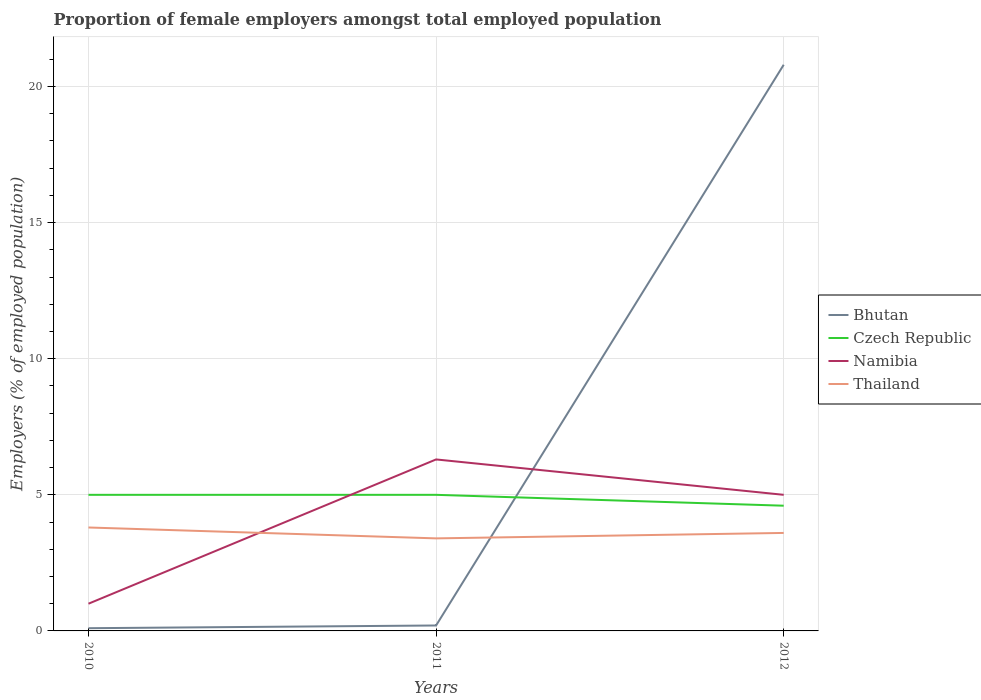How many different coloured lines are there?
Your response must be concise. 4. In which year was the proportion of female employers in Czech Republic maximum?
Keep it short and to the point. 2012. What is the total proportion of female employers in Bhutan in the graph?
Provide a succinct answer. -0.1. What is the difference between the highest and the second highest proportion of female employers in Namibia?
Make the answer very short. 5.3. Are the values on the major ticks of Y-axis written in scientific E-notation?
Your answer should be very brief. No. Does the graph contain grids?
Give a very brief answer. Yes. Where does the legend appear in the graph?
Offer a very short reply. Center right. How many legend labels are there?
Offer a terse response. 4. How are the legend labels stacked?
Give a very brief answer. Vertical. What is the title of the graph?
Your answer should be compact. Proportion of female employers amongst total employed population. What is the label or title of the Y-axis?
Keep it short and to the point. Employers (% of employed population). What is the Employers (% of employed population) of Bhutan in 2010?
Provide a short and direct response. 0.1. What is the Employers (% of employed population) of Namibia in 2010?
Keep it short and to the point. 1. What is the Employers (% of employed population) in Thailand in 2010?
Offer a very short reply. 3.8. What is the Employers (% of employed population) in Bhutan in 2011?
Your answer should be very brief. 0.2. What is the Employers (% of employed population) in Czech Republic in 2011?
Your response must be concise. 5. What is the Employers (% of employed population) of Namibia in 2011?
Provide a short and direct response. 6.3. What is the Employers (% of employed population) in Thailand in 2011?
Offer a very short reply. 3.4. What is the Employers (% of employed population) of Bhutan in 2012?
Provide a short and direct response. 20.8. What is the Employers (% of employed population) in Czech Republic in 2012?
Offer a very short reply. 4.6. What is the Employers (% of employed population) of Thailand in 2012?
Provide a succinct answer. 3.6. Across all years, what is the maximum Employers (% of employed population) in Bhutan?
Give a very brief answer. 20.8. Across all years, what is the maximum Employers (% of employed population) of Czech Republic?
Your answer should be compact. 5. Across all years, what is the maximum Employers (% of employed population) of Namibia?
Your answer should be compact. 6.3. Across all years, what is the maximum Employers (% of employed population) in Thailand?
Provide a short and direct response. 3.8. Across all years, what is the minimum Employers (% of employed population) of Bhutan?
Provide a succinct answer. 0.1. Across all years, what is the minimum Employers (% of employed population) in Czech Republic?
Give a very brief answer. 4.6. Across all years, what is the minimum Employers (% of employed population) of Namibia?
Offer a very short reply. 1. Across all years, what is the minimum Employers (% of employed population) in Thailand?
Provide a succinct answer. 3.4. What is the total Employers (% of employed population) of Bhutan in the graph?
Give a very brief answer. 21.1. What is the total Employers (% of employed population) in Thailand in the graph?
Offer a very short reply. 10.8. What is the difference between the Employers (% of employed population) of Thailand in 2010 and that in 2011?
Give a very brief answer. 0.4. What is the difference between the Employers (% of employed population) in Bhutan in 2010 and that in 2012?
Make the answer very short. -20.7. What is the difference between the Employers (% of employed population) of Namibia in 2010 and that in 2012?
Offer a very short reply. -4. What is the difference between the Employers (% of employed population) of Bhutan in 2011 and that in 2012?
Your answer should be compact. -20.6. What is the difference between the Employers (% of employed population) of Czech Republic in 2011 and that in 2012?
Keep it short and to the point. 0.4. What is the difference between the Employers (% of employed population) of Namibia in 2011 and that in 2012?
Give a very brief answer. 1.3. What is the difference between the Employers (% of employed population) in Thailand in 2011 and that in 2012?
Provide a short and direct response. -0.2. What is the difference between the Employers (% of employed population) in Namibia in 2010 and the Employers (% of employed population) in Thailand in 2011?
Your response must be concise. -2.4. What is the difference between the Employers (% of employed population) in Czech Republic in 2010 and the Employers (% of employed population) in Thailand in 2012?
Your answer should be compact. 1.4. What is the difference between the Employers (% of employed population) of Namibia in 2010 and the Employers (% of employed population) of Thailand in 2012?
Keep it short and to the point. -2.6. What is the difference between the Employers (% of employed population) in Bhutan in 2011 and the Employers (% of employed population) in Namibia in 2012?
Give a very brief answer. -4.8. What is the difference between the Employers (% of employed population) of Czech Republic in 2011 and the Employers (% of employed population) of Thailand in 2012?
Provide a short and direct response. 1.4. What is the average Employers (% of employed population) in Bhutan per year?
Offer a very short reply. 7.03. What is the average Employers (% of employed population) in Czech Republic per year?
Provide a short and direct response. 4.87. What is the average Employers (% of employed population) of Thailand per year?
Provide a succinct answer. 3.6. In the year 2010, what is the difference between the Employers (% of employed population) of Czech Republic and Employers (% of employed population) of Namibia?
Offer a very short reply. 4. In the year 2010, what is the difference between the Employers (% of employed population) of Namibia and Employers (% of employed population) of Thailand?
Keep it short and to the point. -2.8. In the year 2011, what is the difference between the Employers (% of employed population) in Bhutan and Employers (% of employed population) in Namibia?
Your response must be concise. -6.1. In the year 2011, what is the difference between the Employers (% of employed population) of Czech Republic and Employers (% of employed population) of Namibia?
Offer a terse response. -1.3. In the year 2011, what is the difference between the Employers (% of employed population) of Namibia and Employers (% of employed population) of Thailand?
Offer a terse response. 2.9. In the year 2012, what is the difference between the Employers (% of employed population) of Bhutan and Employers (% of employed population) of Czech Republic?
Ensure brevity in your answer.  16.2. In the year 2012, what is the difference between the Employers (% of employed population) in Bhutan and Employers (% of employed population) in Thailand?
Give a very brief answer. 17.2. In the year 2012, what is the difference between the Employers (% of employed population) of Namibia and Employers (% of employed population) of Thailand?
Ensure brevity in your answer.  1.4. What is the ratio of the Employers (% of employed population) of Czech Republic in 2010 to that in 2011?
Your answer should be compact. 1. What is the ratio of the Employers (% of employed population) of Namibia in 2010 to that in 2011?
Provide a succinct answer. 0.16. What is the ratio of the Employers (% of employed population) of Thailand in 2010 to that in 2011?
Provide a succinct answer. 1.12. What is the ratio of the Employers (% of employed population) in Bhutan in 2010 to that in 2012?
Make the answer very short. 0. What is the ratio of the Employers (% of employed population) in Czech Republic in 2010 to that in 2012?
Offer a very short reply. 1.09. What is the ratio of the Employers (% of employed population) in Namibia in 2010 to that in 2012?
Ensure brevity in your answer.  0.2. What is the ratio of the Employers (% of employed population) in Thailand in 2010 to that in 2012?
Provide a short and direct response. 1.06. What is the ratio of the Employers (% of employed population) in Bhutan in 2011 to that in 2012?
Your response must be concise. 0.01. What is the ratio of the Employers (% of employed population) of Czech Republic in 2011 to that in 2012?
Offer a terse response. 1.09. What is the ratio of the Employers (% of employed population) in Namibia in 2011 to that in 2012?
Your response must be concise. 1.26. What is the ratio of the Employers (% of employed population) of Thailand in 2011 to that in 2012?
Your answer should be compact. 0.94. What is the difference between the highest and the second highest Employers (% of employed population) of Bhutan?
Make the answer very short. 20.6. What is the difference between the highest and the second highest Employers (% of employed population) in Czech Republic?
Your response must be concise. 0. What is the difference between the highest and the lowest Employers (% of employed population) in Bhutan?
Ensure brevity in your answer.  20.7. What is the difference between the highest and the lowest Employers (% of employed population) of Czech Republic?
Your answer should be compact. 0.4. 